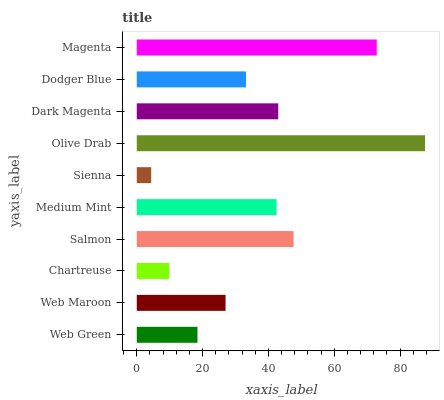Is Sienna the minimum?
Answer yes or no. Yes. Is Olive Drab the maximum?
Answer yes or no. Yes. Is Web Maroon the minimum?
Answer yes or no. No. Is Web Maroon the maximum?
Answer yes or no. No. Is Web Maroon greater than Web Green?
Answer yes or no. Yes. Is Web Green less than Web Maroon?
Answer yes or no. Yes. Is Web Green greater than Web Maroon?
Answer yes or no. No. Is Web Maroon less than Web Green?
Answer yes or no. No. Is Medium Mint the high median?
Answer yes or no. Yes. Is Dodger Blue the low median?
Answer yes or no. Yes. Is Olive Drab the high median?
Answer yes or no. No. Is Salmon the low median?
Answer yes or no. No. 